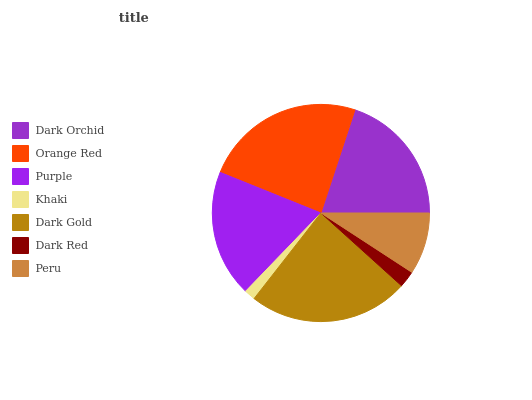Is Khaki the minimum?
Answer yes or no. Yes. Is Orange Red the maximum?
Answer yes or no. Yes. Is Purple the minimum?
Answer yes or no. No. Is Purple the maximum?
Answer yes or no. No. Is Orange Red greater than Purple?
Answer yes or no. Yes. Is Purple less than Orange Red?
Answer yes or no. Yes. Is Purple greater than Orange Red?
Answer yes or no. No. Is Orange Red less than Purple?
Answer yes or no. No. Is Purple the high median?
Answer yes or no. Yes. Is Purple the low median?
Answer yes or no. Yes. Is Peru the high median?
Answer yes or no. No. Is Khaki the low median?
Answer yes or no. No. 